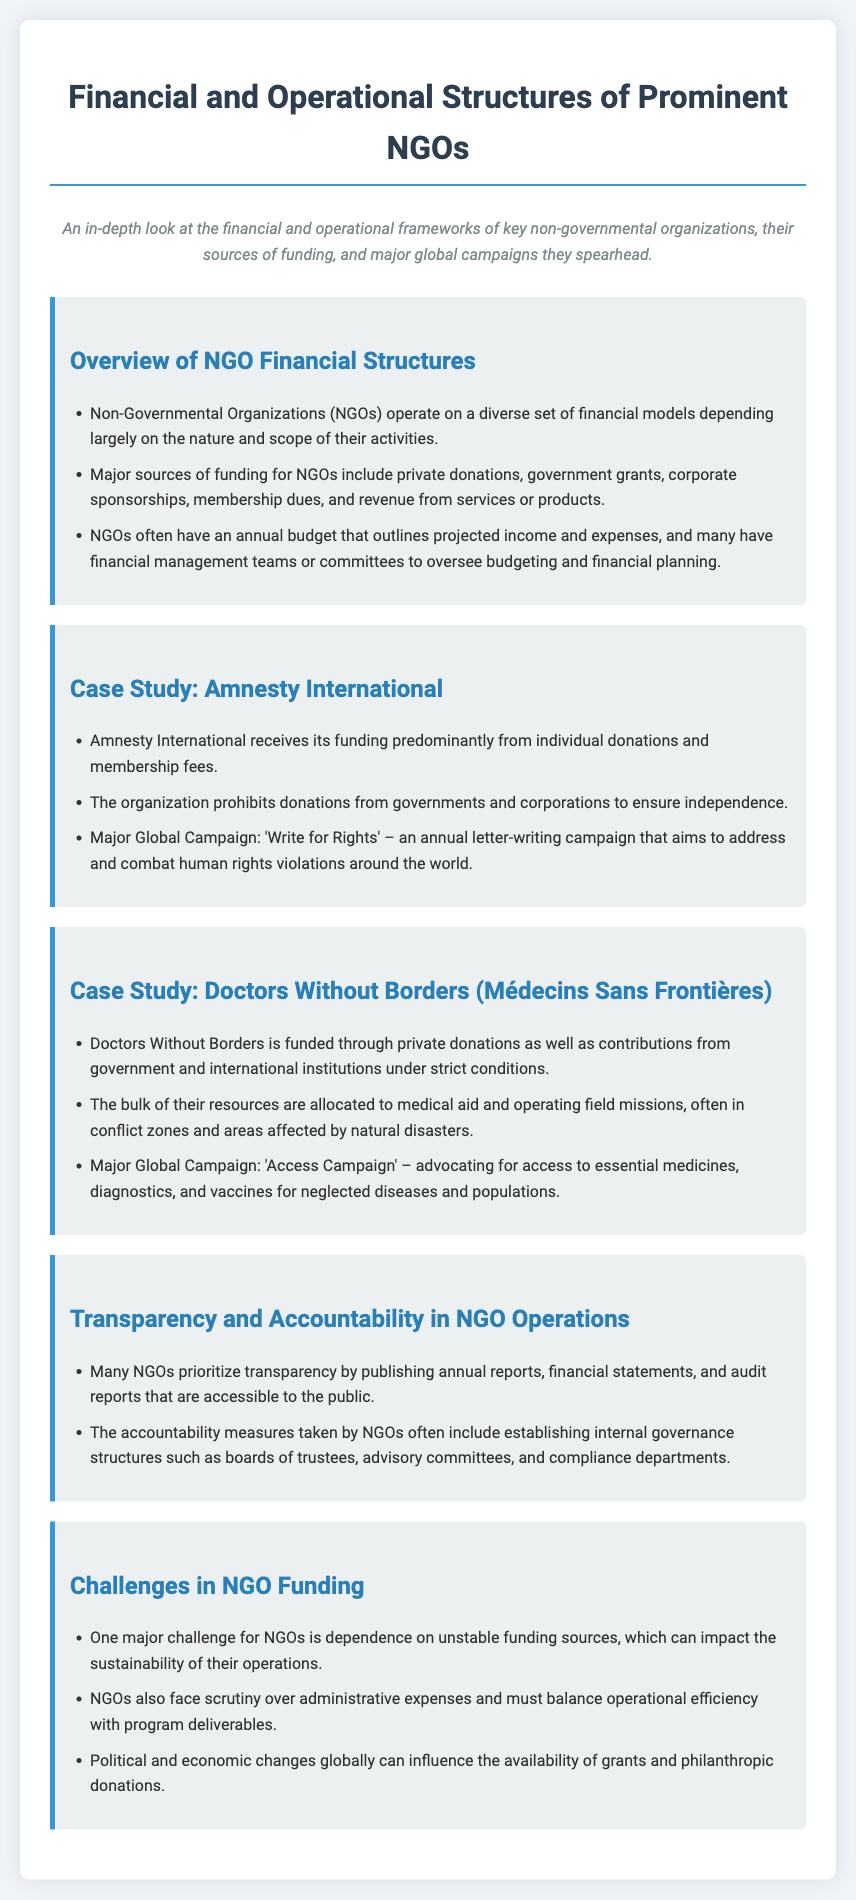What is the major source of funding for Amnesty International? Amnesty International's funding primarily comes from individual donations and membership fees as stated in the case study.
Answer: individual donations and membership fees What campaign does Doctors Without Borders lead? The document mentions that Doctors Without Borders has a major global campaign called the 'Access Campaign'.
Answer: Access Campaign What financial management practice is common among NGOs? The document indicates that NGOs often have financial management teams or committees to oversee budgeting and financial planning.
Answer: financial management teams or committees Which major challenge do NGOs face regarding funding? One of the challenges highlighted is the dependence on unstable funding sources, which affects their operational sustainability.
Answer: dependence on unstable funding sources What is the main prohibition of Amnesty International regarding funding? Amnesty International prohibits donations from governments and corporations to maintain its independence as described in the case study.
Answer: donations from governments and corporations How does the document describe transparency in NGOs? The document states that many NGOs prioritize transparency by publishing annual reports, financial statements, and audit reports.
Answer: publishing annual reports, financial statements, and audit reports What is one way NGOs establish accountability? NGOs establish accountability measures through governance structures such as boards of trustees and advisory committees as mentioned in the document.
Answer: boards of trustees and advisory committees What is the annual campaign of Amnesty International called? The document refers to Amnesty International's annual campaign as 'Write for Rights'.
Answer: Write for Rights 